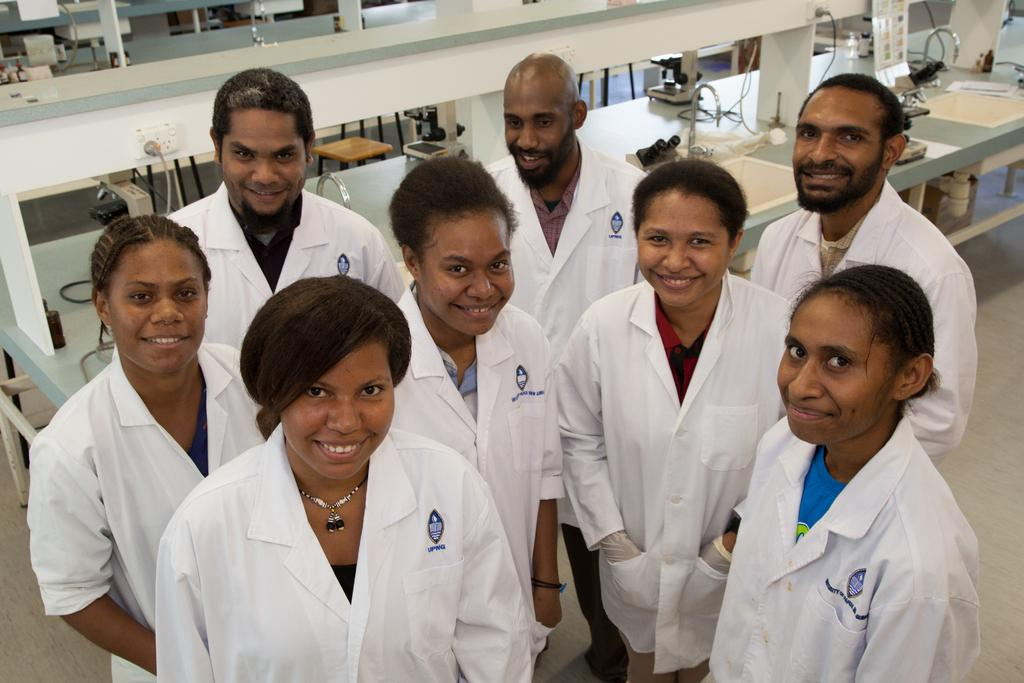Who is present in the image? There are people in the image. What are the people wearing? The people are wearing white aprons. What can be seen in the background of the image? There are desks in the image. What is placed on the desks? There are things placed on the desks. How many dimes can be seen on the desks in the image? There is no mention of dimes in the image, so it is impossible to determine how many dimes are present. 